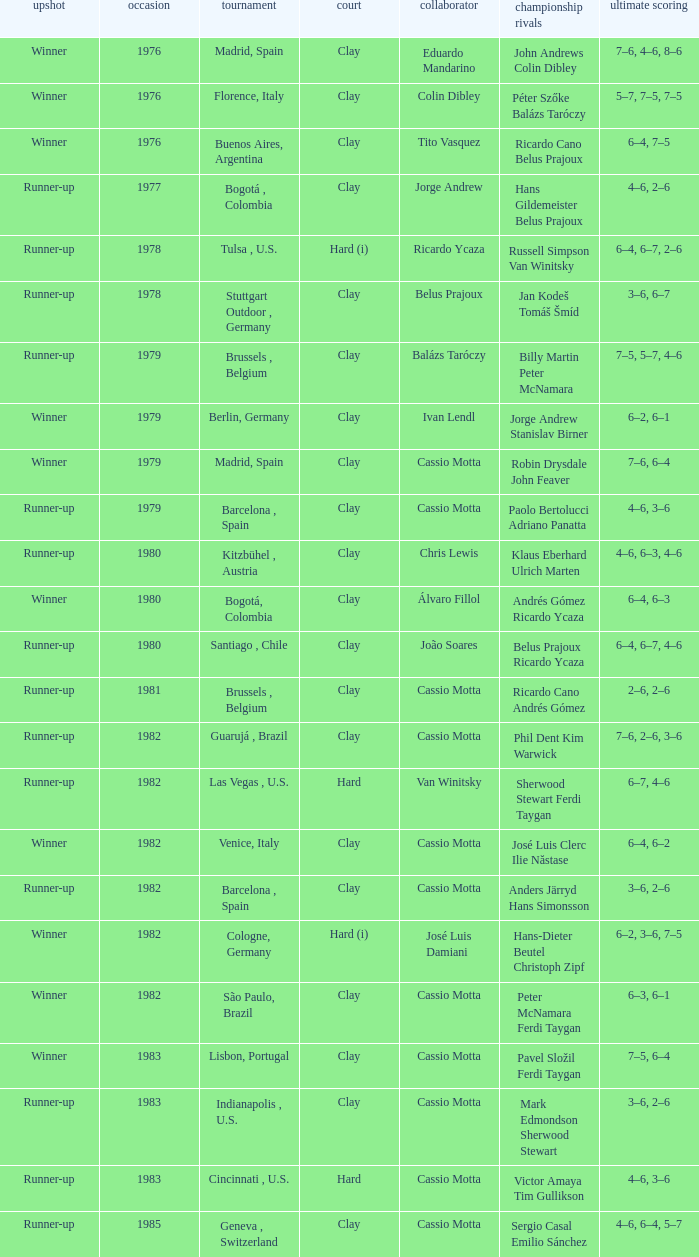Can you give me this table as a dict? {'header': ['upshot', 'occasion', 'tournament', 'court', 'collaborator', 'championship rivals', 'ultimate scoring'], 'rows': [['Winner', '1976', 'Madrid, Spain', 'Clay', 'Eduardo Mandarino', 'John Andrews Colin Dibley', '7–6, 4–6, 8–6'], ['Winner', '1976', 'Florence, Italy', 'Clay', 'Colin Dibley', 'Péter Szőke Balázs Taróczy', '5–7, 7–5, 7–5'], ['Winner', '1976', 'Buenos Aires, Argentina', 'Clay', 'Tito Vasquez', 'Ricardo Cano Belus Prajoux', '6–4, 7–5'], ['Runner-up', '1977', 'Bogotá , Colombia', 'Clay', 'Jorge Andrew', 'Hans Gildemeister Belus Prajoux', '4–6, 2–6'], ['Runner-up', '1978', 'Tulsa , U.S.', 'Hard (i)', 'Ricardo Ycaza', 'Russell Simpson Van Winitsky', '6–4, 6–7, 2–6'], ['Runner-up', '1978', 'Stuttgart Outdoor , Germany', 'Clay', 'Belus Prajoux', 'Jan Kodeš Tomáš Šmíd', '3–6, 6–7'], ['Runner-up', '1979', 'Brussels , Belgium', 'Clay', 'Balázs Taróczy', 'Billy Martin Peter McNamara', '7–5, 5–7, 4–6'], ['Winner', '1979', 'Berlin, Germany', 'Clay', 'Ivan Lendl', 'Jorge Andrew Stanislav Birner', '6–2, 6–1'], ['Winner', '1979', 'Madrid, Spain', 'Clay', 'Cassio Motta', 'Robin Drysdale John Feaver', '7–6, 6–4'], ['Runner-up', '1979', 'Barcelona , Spain', 'Clay', 'Cassio Motta', 'Paolo Bertolucci Adriano Panatta', '4–6, 3–6'], ['Runner-up', '1980', 'Kitzbühel , Austria', 'Clay', 'Chris Lewis', 'Klaus Eberhard Ulrich Marten', '4–6, 6–3, 4–6'], ['Winner', '1980', 'Bogotá, Colombia', 'Clay', 'Álvaro Fillol', 'Andrés Gómez Ricardo Ycaza', '6–4, 6–3'], ['Runner-up', '1980', 'Santiago , Chile', 'Clay', 'João Soares', 'Belus Prajoux Ricardo Ycaza', '6–4, 6–7, 4–6'], ['Runner-up', '1981', 'Brussels , Belgium', 'Clay', 'Cassio Motta', 'Ricardo Cano Andrés Gómez', '2–6, 2–6'], ['Runner-up', '1982', 'Guarujá , Brazil', 'Clay', 'Cassio Motta', 'Phil Dent Kim Warwick', '7–6, 2–6, 3–6'], ['Runner-up', '1982', 'Las Vegas , U.S.', 'Hard', 'Van Winitsky', 'Sherwood Stewart Ferdi Taygan', '6–7, 4–6'], ['Winner', '1982', 'Venice, Italy', 'Clay', 'Cassio Motta', 'José Luis Clerc Ilie Năstase', '6–4, 6–2'], ['Runner-up', '1982', 'Barcelona , Spain', 'Clay', 'Cassio Motta', 'Anders Järryd Hans Simonsson', '3–6, 2–6'], ['Winner', '1982', 'Cologne, Germany', 'Hard (i)', 'José Luis Damiani', 'Hans-Dieter Beutel Christoph Zipf', '6–2, 3–6, 7–5'], ['Winner', '1982', 'São Paulo, Brazil', 'Clay', 'Cassio Motta', 'Peter McNamara Ferdi Taygan', '6–3, 6–1'], ['Winner', '1983', 'Lisbon, Portugal', 'Clay', 'Cassio Motta', 'Pavel Složil Ferdi Taygan', '7–5, 6–4'], ['Runner-up', '1983', 'Indianapolis , U.S.', 'Clay', 'Cassio Motta', 'Mark Edmondson Sherwood Stewart', '3–6, 2–6'], ['Runner-up', '1983', 'Cincinnati , U.S.', 'Hard', 'Cassio Motta', 'Victor Amaya Tim Gullikson', '4–6, 3–6'], ['Runner-up', '1985', 'Geneva , Switzerland', 'Clay', 'Cassio Motta', 'Sergio Casal Emilio Sánchez', '4–6, 6–4, 5–7']]} What is the outcome on a hard surface, when the score in the final was 4–6, 3–6? Runner-up. 